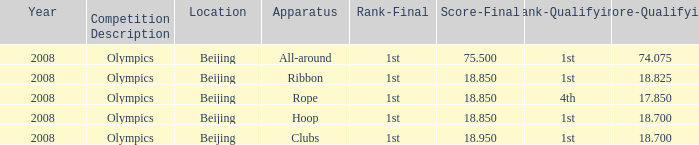When her qualifying score was 74.075, what was the lowest final score she achieved? 75.5. 